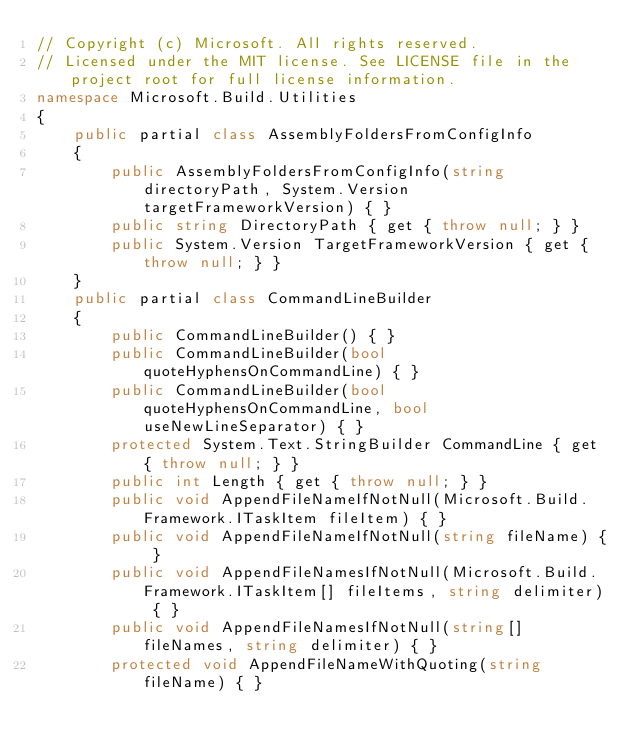Convert code to text. <code><loc_0><loc_0><loc_500><loc_500><_C#_>// Copyright (c) Microsoft. All rights reserved.
// Licensed under the MIT license. See LICENSE file in the project root for full license information.
namespace Microsoft.Build.Utilities
{
    public partial class AssemblyFoldersFromConfigInfo
    {
        public AssemblyFoldersFromConfigInfo(string directoryPath, System.Version targetFrameworkVersion) { }
        public string DirectoryPath { get { throw null; } }
        public System.Version TargetFrameworkVersion { get { throw null; } }
    }
    public partial class CommandLineBuilder
    {
        public CommandLineBuilder() { }
        public CommandLineBuilder(bool quoteHyphensOnCommandLine) { }
        public CommandLineBuilder(bool quoteHyphensOnCommandLine, bool useNewLineSeparator) { }
        protected System.Text.StringBuilder CommandLine { get { throw null; } }
        public int Length { get { throw null; } }
        public void AppendFileNameIfNotNull(Microsoft.Build.Framework.ITaskItem fileItem) { }
        public void AppendFileNameIfNotNull(string fileName) { }
        public void AppendFileNamesIfNotNull(Microsoft.Build.Framework.ITaskItem[] fileItems, string delimiter) { }
        public void AppendFileNamesIfNotNull(string[] fileNames, string delimiter) { }
        protected void AppendFileNameWithQuoting(string fileName) { }</code> 